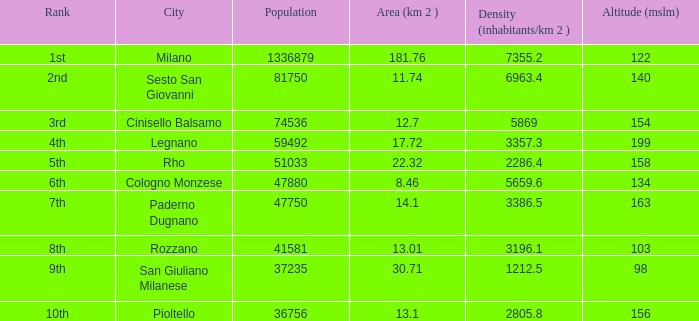Which Altitude (mslm) is the highest one that has an Area (km 2) smaller than 13.01, and a Population of 74536, and a Density (inhabitants/km 2) larger than 5869? None. 